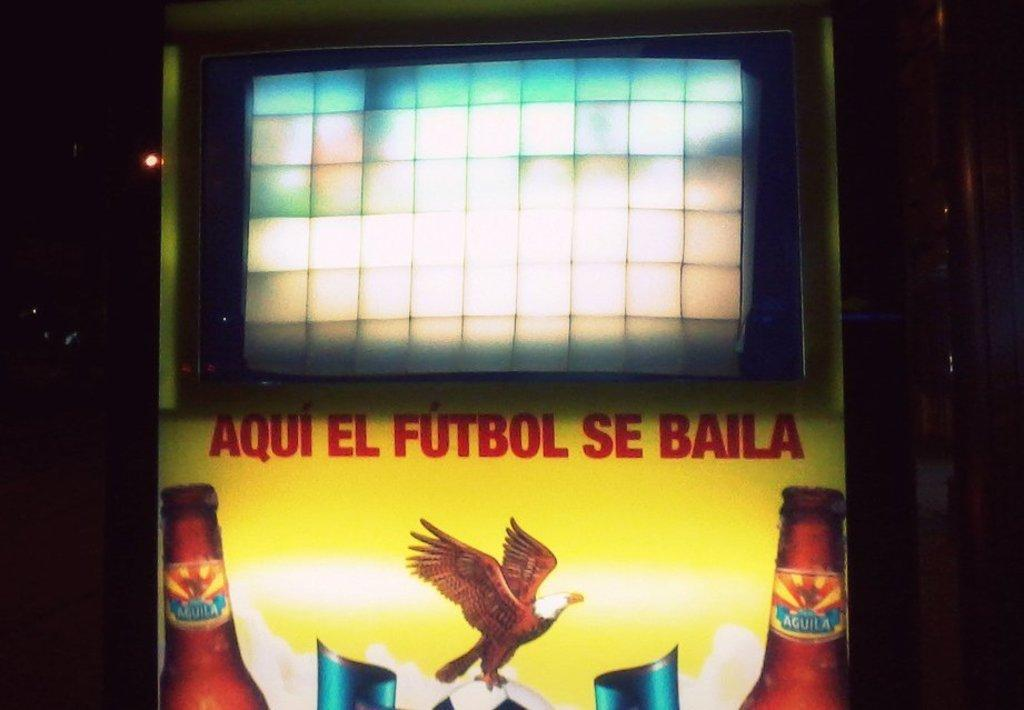<image>
Present a compact description of the photo's key features. A sign that reads "Aqui el Futbol se baila" with an eagle, a soccer ball, and two beer bottles below it. 